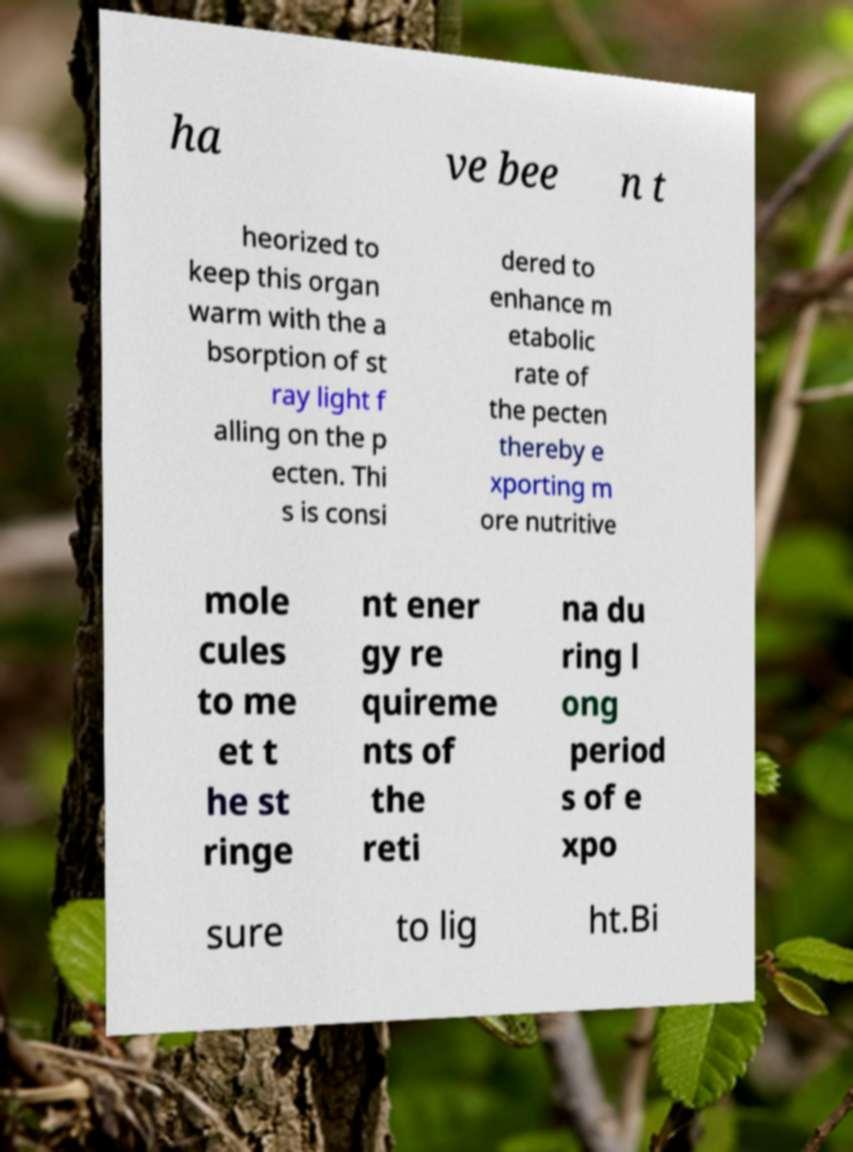What messages or text are displayed in this image? I need them in a readable, typed format. ha ve bee n t heorized to keep this organ warm with the a bsorption of st ray light f alling on the p ecten. Thi s is consi dered to enhance m etabolic rate of the pecten thereby e xporting m ore nutritive mole cules to me et t he st ringe nt ener gy re quireme nts of the reti na du ring l ong period s of e xpo sure to lig ht.Bi 